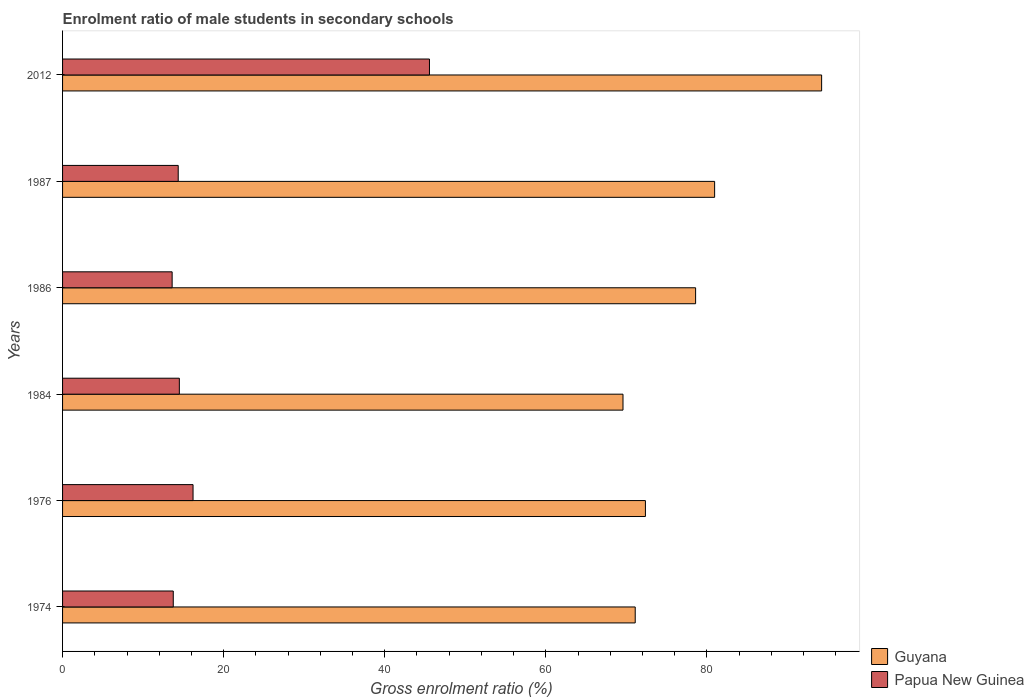How many different coloured bars are there?
Offer a very short reply. 2. How many groups of bars are there?
Your answer should be very brief. 6. Are the number of bars per tick equal to the number of legend labels?
Give a very brief answer. Yes. Are the number of bars on each tick of the Y-axis equal?
Keep it short and to the point. Yes. How many bars are there on the 1st tick from the top?
Make the answer very short. 2. What is the label of the 5th group of bars from the top?
Offer a very short reply. 1976. In how many cases, is the number of bars for a given year not equal to the number of legend labels?
Offer a terse response. 0. What is the enrolment ratio of male students in secondary schools in Papua New Guinea in 2012?
Your answer should be compact. 45.56. Across all years, what is the maximum enrolment ratio of male students in secondary schools in Papua New Guinea?
Provide a succinct answer. 45.56. Across all years, what is the minimum enrolment ratio of male students in secondary schools in Papua New Guinea?
Provide a short and direct response. 13.61. In which year was the enrolment ratio of male students in secondary schools in Guyana maximum?
Offer a very short reply. 2012. In which year was the enrolment ratio of male students in secondary schools in Papua New Guinea minimum?
Offer a terse response. 1986. What is the total enrolment ratio of male students in secondary schools in Guyana in the graph?
Provide a succinct answer. 466.87. What is the difference between the enrolment ratio of male students in secondary schools in Papua New Guinea in 1987 and that in 2012?
Make the answer very short. -31.2. What is the difference between the enrolment ratio of male students in secondary schools in Guyana in 1986 and the enrolment ratio of male students in secondary schools in Papua New Guinea in 1974?
Provide a short and direct response. 64.86. What is the average enrolment ratio of male students in secondary schools in Guyana per year?
Provide a succinct answer. 77.81. In the year 1987, what is the difference between the enrolment ratio of male students in secondary schools in Papua New Guinea and enrolment ratio of male students in secondary schools in Guyana?
Ensure brevity in your answer.  -66.6. In how many years, is the enrolment ratio of male students in secondary schools in Guyana greater than 24 %?
Ensure brevity in your answer.  6. What is the ratio of the enrolment ratio of male students in secondary schools in Guyana in 1974 to that in 1987?
Provide a succinct answer. 0.88. Is the enrolment ratio of male students in secondary schools in Guyana in 1987 less than that in 2012?
Your answer should be compact. Yes. What is the difference between the highest and the second highest enrolment ratio of male students in secondary schools in Papua New Guinea?
Provide a short and direct response. 29.36. What is the difference between the highest and the lowest enrolment ratio of male students in secondary schools in Papua New Guinea?
Offer a very short reply. 31.95. Is the sum of the enrolment ratio of male students in secondary schools in Papua New Guinea in 1984 and 1987 greater than the maximum enrolment ratio of male students in secondary schools in Guyana across all years?
Keep it short and to the point. No. What does the 2nd bar from the top in 2012 represents?
Offer a terse response. Guyana. What does the 2nd bar from the bottom in 1976 represents?
Offer a terse response. Papua New Guinea. Are all the bars in the graph horizontal?
Make the answer very short. Yes. What is the difference between two consecutive major ticks on the X-axis?
Your answer should be compact. 20. Are the values on the major ticks of X-axis written in scientific E-notation?
Offer a very short reply. No. How are the legend labels stacked?
Your answer should be very brief. Vertical. What is the title of the graph?
Make the answer very short. Enrolment ratio of male students in secondary schools. Does "Azerbaijan" appear as one of the legend labels in the graph?
Your answer should be very brief. No. What is the label or title of the X-axis?
Give a very brief answer. Gross enrolment ratio (%). What is the Gross enrolment ratio (%) of Guyana in 1974?
Ensure brevity in your answer.  71.1. What is the Gross enrolment ratio (%) of Papua New Guinea in 1974?
Make the answer very short. 13.75. What is the Gross enrolment ratio (%) of Guyana in 1976?
Provide a succinct answer. 72.37. What is the Gross enrolment ratio (%) in Papua New Guinea in 1976?
Make the answer very short. 16.2. What is the Gross enrolment ratio (%) in Guyana in 1984?
Keep it short and to the point. 69.59. What is the Gross enrolment ratio (%) of Papua New Guinea in 1984?
Keep it short and to the point. 14.5. What is the Gross enrolment ratio (%) of Guyana in 1986?
Your answer should be very brief. 78.6. What is the Gross enrolment ratio (%) of Papua New Guinea in 1986?
Provide a short and direct response. 13.61. What is the Gross enrolment ratio (%) in Guyana in 1987?
Your answer should be compact. 80.96. What is the Gross enrolment ratio (%) of Papua New Guinea in 1987?
Provide a short and direct response. 14.36. What is the Gross enrolment ratio (%) in Guyana in 2012?
Ensure brevity in your answer.  94.25. What is the Gross enrolment ratio (%) of Papua New Guinea in 2012?
Keep it short and to the point. 45.56. Across all years, what is the maximum Gross enrolment ratio (%) in Guyana?
Keep it short and to the point. 94.25. Across all years, what is the maximum Gross enrolment ratio (%) in Papua New Guinea?
Keep it short and to the point. 45.56. Across all years, what is the minimum Gross enrolment ratio (%) of Guyana?
Provide a short and direct response. 69.59. Across all years, what is the minimum Gross enrolment ratio (%) of Papua New Guinea?
Provide a succinct answer. 13.61. What is the total Gross enrolment ratio (%) of Guyana in the graph?
Your answer should be very brief. 466.87. What is the total Gross enrolment ratio (%) in Papua New Guinea in the graph?
Your answer should be very brief. 117.97. What is the difference between the Gross enrolment ratio (%) of Guyana in 1974 and that in 1976?
Your response must be concise. -1.27. What is the difference between the Gross enrolment ratio (%) of Papua New Guinea in 1974 and that in 1976?
Give a very brief answer. -2.46. What is the difference between the Gross enrolment ratio (%) of Guyana in 1974 and that in 1984?
Your response must be concise. 1.52. What is the difference between the Gross enrolment ratio (%) in Papua New Guinea in 1974 and that in 1984?
Your response must be concise. -0.76. What is the difference between the Gross enrolment ratio (%) of Guyana in 1974 and that in 1986?
Your response must be concise. -7.5. What is the difference between the Gross enrolment ratio (%) of Papua New Guinea in 1974 and that in 1986?
Your answer should be compact. 0.14. What is the difference between the Gross enrolment ratio (%) in Guyana in 1974 and that in 1987?
Your answer should be very brief. -9.86. What is the difference between the Gross enrolment ratio (%) in Papua New Guinea in 1974 and that in 1987?
Your answer should be compact. -0.61. What is the difference between the Gross enrolment ratio (%) in Guyana in 1974 and that in 2012?
Provide a short and direct response. -23.15. What is the difference between the Gross enrolment ratio (%) in Papua New Guinea in 1974 and that in 2012?
Provide a succinct answer. -31.81. What is the difference between the Gross enrolment ratio (%) of Guyana in 1976 and that in 1984?
Ensure brevity in your answer.  2.78. What is the difference between the Gross enrolment ratio (%) of Papua New Guinea in 1976 and that in 1984?
Provide a succinct answer. 1.7. What is the difference between the Gross enrolment ratio (%) of Guyana in 1976 and that in 1986?
Offer a terse response. -6.23. What is the difference between the Gross enrolment ratio (%) of Papua New Guinea in 1976 and that in 1986?
Give a very brief answer. 2.6. What is the difference between the Gross enrolment ratio (%) of Guyana in 1976 and that in 1987?
Your answer should be compact. -8.59. What is the difference between the Gross enrolment ratio (%) in Papua New Guinea in 1976 and that in 1987?
Make the answer very short. 1.84. What is the difference between the Gross enrolment ratio (%) of Guyana in 1976 and that in 2012?
Ensure brevity in your answer.  -21.88. What is the difference between the Gross enrolment ratio (%) in Papua New Guinea in 1976 and that in 2012?
Your response must be concise. -29.36. What is the difference between the Gross enrolment ratio (%) in Guyana in 1984 and that in 1986?
Keep it short and to the point. -9.02. What is the difference between the Gross enrolment ratio (%) in Papua New Guinea in 1984 and that in 1986?
Provide a succinct answer. 0.9. What is the difference between the Gross enrolment ratio (%) of Guyana in 1984 and that in 1987?
Provide a succinct answer. -11.38. What is the difference between the Gross enrolment ratio (%) in Papua New Guinea in 1984 and that in 1987?
Your answer should be very brief. 0.14. What is the difference between the Gross enrolment ratio (%) in Guyana in 1984 and that in 2012?
Offer a terse response. -24.66. What is the difference between the Gross enrolment ratio (%) in Papua New Guinea in 1984 and that in 2012?
Make the answer very short. -31.06. What is the difference between the Gross enrolment ratio (%) of Guyana in 1986 and that in 1987?
Your answer should be compact. -2.36. What is the difference between the Gross enrolment ratio (%) of Papua New Guinea in 1986 and that in 1987?
Make the answer very short. -0.75. What is the difference between the Gross enrolment ratio (%) in Guyana in 1986 and that in 2012?
Keep it short and to the point. -15.65. What is the difference between the Gross enrolment ratio (%) of Papua New Guinea in 1986 and that in 2012?
Give a very brief answer. -31.95. What is the difference between the Gross enrolment ratio (%) in Guyana in 1987 and that in 2012?
Provide a short and direct response. -13.29. What is the difference between the Gross enrolment ratio (%) in Papua New Guinea in 1987 and that in 2012?
Offer a terse response. -31.2. What is the difference between the Gross enrolment ratio (%) in Guyana in 1974 and the Gross enrolment ratio (%) in Papua New Guinea in 1976?
Make the answer very short. 54.9. What is the difference between the Gross enrolment ratio (%) in Guyana in 1974 and the Gross enrolment ratio (%) in Papua New Guinea in 1984?
Provide a short and direct response. 56.6. What is the difference between the Gross enrolment ratio (%) of Guyana in 1974 and the Gross enrolment ratio (%) of Papua New Guinea in 1986?
Offer a very short reply. 57.5. What is the difference between the Gross enrolment ratio (%) in Guyana in 1974 and the Gross enrolment ratio (%) in Papua New Guinea in 1987?
Offer a very short reply. 56.74. What is the difference between the Gross enrolment ratio (%) in Guyana in 1974 and the Gross enrolment ratio (%) in Papua New Guinea in 2012?
Provide a short and direct response. 25.55. What is the difference between the Gross enrolment ratio (%) of Guyana in 1976 and the Gross enrolment ratio (%) of Papua New Guinea in 1984?
Offer a terse response. 57.87. What is the difference between the Gross enrolment ratio (%) of Guyana in 1976 and the Gross enrolment ratio (%) of Papua New Guinea in 1986?
Make the answer very short. 58.77. What is the difference between the Gross enrolment ratio (%) of Guyana in 1976 and the Gross enrolment ratio (%) of Papua New Guinea in 1987?
Your response must be concise. 58.01. What is the difference between the Gross enrolment ratio (%) of Guyana in 1976 and the Gross enrolment ratio (%) of Papua New Guinea in 2012?
Your answer should be compact. 26.81. What is the difference between the Gross enrolment ratio (%) in Guyana in 1984 and the Gross enrolment ratio (%) in Papua New Guinea in 1986?
Provide a succinct answer. 55.98. What is the difference between the Gross enrolment ratio (%) in Guyana in 1984 and the Gross enrolment ratio (%) in Papua New Guinea in 1987?
Give a very brief answer. 55.23. What is the difference between the Gross enrolment ratio (%) in Guyana in 1984 and the Gross enrolment ratio (%) in Papua New Guinea in 2012?
Your response must be concise. 24.03. What is the difference between the Gross enrolment ratio (%) of Guyana in 1986 and the Gross enrolment ratio (%) of Papua New Guinea in 1987?
Your response must be concise. 64.24. What is the difference between the Gross enrolment ratio (%) of Guyana in 1986 and the Gross enrolment ratio (%) of Papua New Guinea in 2012?
Offer a terse response. 33.04. What is the difference between the Gross enrolment ratio (%) in Guyana in 1987 and the Gross enrolment ratio (%) in Papua New Guinea in 2012?
Give a very brief answer. 35.41. What is the average Gross enrolment ratio (%) in Guyana per year?
Your response must be concise. 77.81. What is the average Gross enrolment ratio (%) of Papua New Guinea per year?
Ensure brevity in your answer.  19.66. In the year 1974, what is the difference between the Gross enrolment ratio (%) of Guyana and Gross enrolment ratio (%) of Papua New Guinea?
Ensure brevity in your answer.  57.36. In the year 1976, what is the difference between the Gross enrolment ratio (%) in Guyana and Gross enrolment ratio (%) in Papua New Guinea?
Offer a terse response. 56.17. In the year 1984, what is the difference between the Gross enrolment ratio (%) in Guyana and Gross enrolment ratio (%) in Papua New Guinea?
Your answer should be compact. 55.09. In the year 1986, what is the difference between the Gross enrolment ratio (%) of Guyana and Gross enrolment ratio (%) of Papua New Guinea?
Make the answer very short. 65. In the year 1987, what is the difference between the Gross enrolment ratio (%) of Guyana and Gross enrolment ratio (%) of Papua New Guinea?
Ensure brevity in your answer.  66.6. In the year 2012, what is the difference between the Gross enrolment ratio (%) of Guyana and Gross enrolment ratio (%) of Papua New Guinea?
Offer a terse response. 48.69. What is the ratio of the Gross enrolment ratio (%) of Guyana in 1974 to that in 1976?
Your answer should be very brief. 0.98. What is the ratio of the Gross enrolment ratio (%) of Papua New Guinea in 1974 to that in 1976?
Make the answer very short. 0.85. What is the ratio of the Gross enrolment ratio (%) of Guyana in 1974 to that in 1984?
Make the answer very short. 1.02. What is the ratio of the Gross enrolment ratio (%) of Papua New Guinea in 1974 to that in 1984?
Make the answer very short. 0.95. What is the ratio of the Gross enrolment ratio (%) of Guyana in 1974 to that in 1986?
Offer a terse response. 0.9. What is the ratio of the Gross enrolment ratio (%) in Papua New Guinea in 1974 to that in 1986?
Ensure brevity in your answer.  1.01. What is the ratio of the Gross enrolment ratio (%) of Guyana in 1974 to that in 1987?
Ensure brevity in your answer.  0.88. What is the ratio of the Gross enrolment ratio (%) of Papua New Guinea in 1974 to that in 1987?
Keep it short and to the point. 0.96. What is the ratio of the Gross enrolment ratio (%) of Guyana in 1974 to that in 2012?
Your response must be concise. 0.75. What is the ratio of the Gross enrolment ratio (%) of Papua New Guinea in 1974 to that in 2012?
Keep it short and to the point. 0.3. What is the ratio of the Gross enrolment ratio (%) in Guyana in 1976 to that in 1984?
Offer a terse response. 1.04. What is the ratio of the Gross enrolment ratio (%) of Papua New Guinea in 1976 to that in 1984?
Your response must be concise. 1.12. What is the ratio of the Gross enrolment ratio (%) of Guyana in 1976 to that in 1986?
Your answer should be very brief. 0.92. What is the ratio of the Gross enrolment ratio (%) of Papua New Guinea in 1976 to that in 1986?
Offer a very short reply. 1.19. What is the ratio of the Gross enrolment ratio (%) in Guyana in 1976 to that in 1987?
Make the answer very short. 0.89. What is the ratio of the Gross enrolment ratio (%) of Papua New Guinea in 1976 to that in 1987?
Your response must be concise. 1.13. What is the ratio of the Gross enrolment ratio (%) of Guyana in 1976 to that in 2012?
Make the answer very short. 0.77. What is the ratio of the Gross enrolment ratio (%) of Papua New Guinea in 1976 to that in 2012?
Offer a very short reply. 0.36. What is the ratio of the Gross enrolment ratio (%) in Guyana in 1984 to that in 1986?
Ensure brevity in your answer.  0.89. What is the ratio of the Gross enrolment ratio (%) in Papua New Guinea in 1984 to that in 1986?
Give a very brief answer. 1.07. What is the ratio of the Gross enrolment ratio (%) in Guyana in 1984 to that in 1987?
Your answer should be compact. 0.86. What is the ratio of the Gross enrolment ratio (%) in Papua New Guinea in 1984 to that in 1987?
Your response must be concise. 1.01. What is the ratio of the Gross enrolment ratio (%) of Guyana in 1984 to that in 2012?
Provide a short and direct response. 0.74. What is the ratio of the Gross enrolment ratio (%) of Papua New Guinea in 1984 to that in 2012?
Offer a very short reply. 0.32. What is the ratio of the Gross enrolment ratio (%) in Guyana in 1986 to that in 1987?
Your answer should be very brief. 0.97. What is the ratio of the Gross enrolment ratio (%) of Papua New Guinea in 1986 to that in 1987?
Ensure brevity in your answer.  0.95. What is the ratio of the Gross enrolment ratio (%) in Guyana in 1986 to that in 2012?
Offer a very short reply. 0.83. What is the ratio of the Gross enrolment ratio (%) of Papua New Guinea in 1986 to that in 2012?
Ensure brevity in your answer.  0.3. What is the ratio of the Gross enrolment ratio (%) in Guyana in 1987 to that in 2012?
Provide a succinct answer. 0.86. What is the ratio of the Gross enrolment ratio (%) of Papua New Guinea in 1987 to that in 2012?
Offer a terse response. 0.32. What is the difference between the highest and the second highest Gross enrolment ratio (%) in Guyana?
Offer a very short reply. 13.29. What is the difference between the highest and the second highest Gross enrolment ratio (%) in Papua New Guinea?
Ensure brevity in your answer.  29.36. What is the difference between the highest and the lowest Gross enrolment ratio (%) in Guyana?
Keep it short and to the point. 24.66. What is the difference between the highest and the lowest Gross enrolment ratio (%) in Papua New Guinea?
Your answer should be compact. 31.95. 